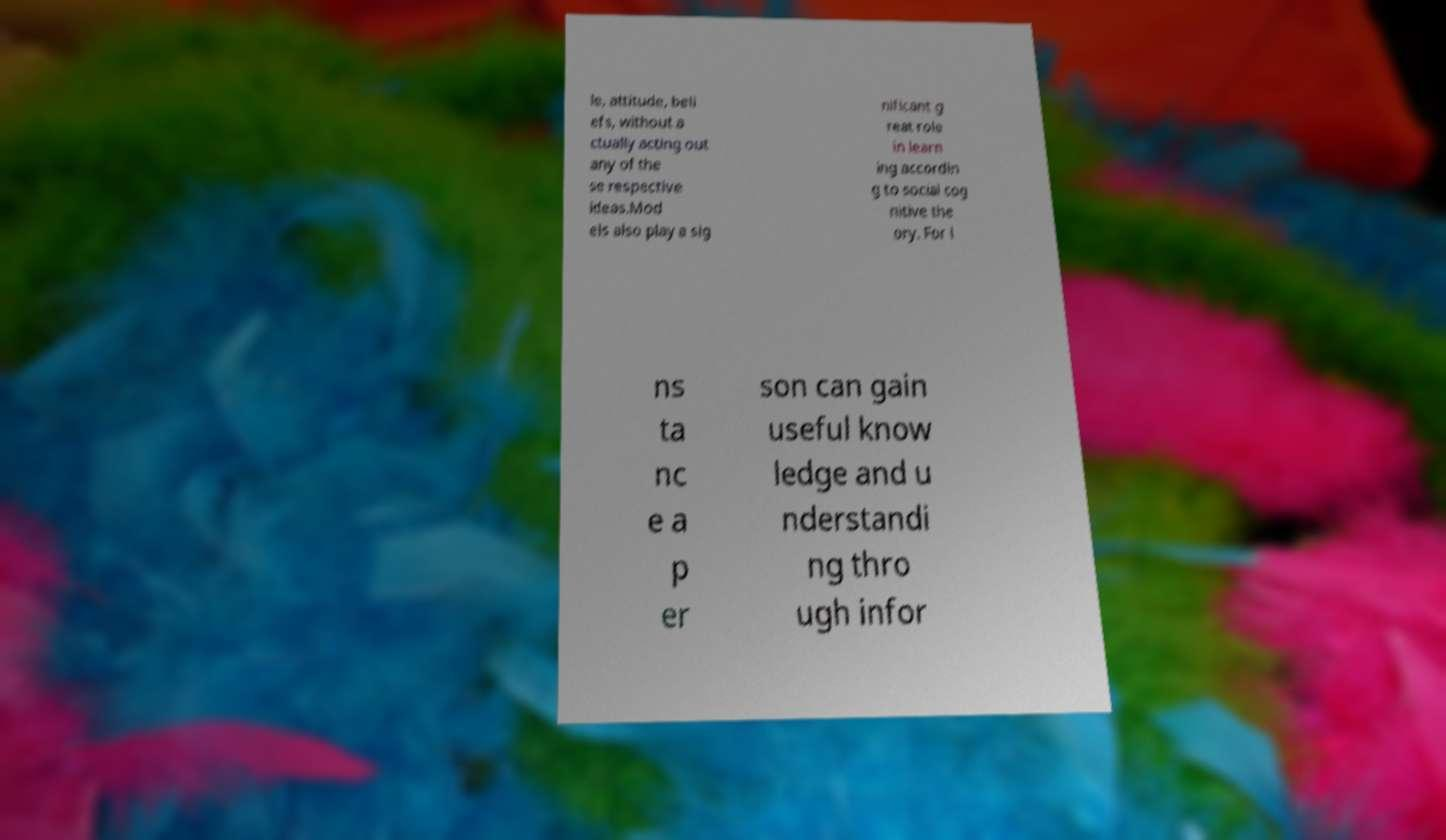For documentation purposes, I need the text within this image transcribed. Could you provide that? le, attitude, beli efs, without a ctually acting out any of the se respective ideas.Mod els also play a sig nificant g reat role in learn ing accordin g to social cog nitive the ory. For i ns ta nc e a p er son can gain useful know ledge and u nderstandi ng thro ugh infor 